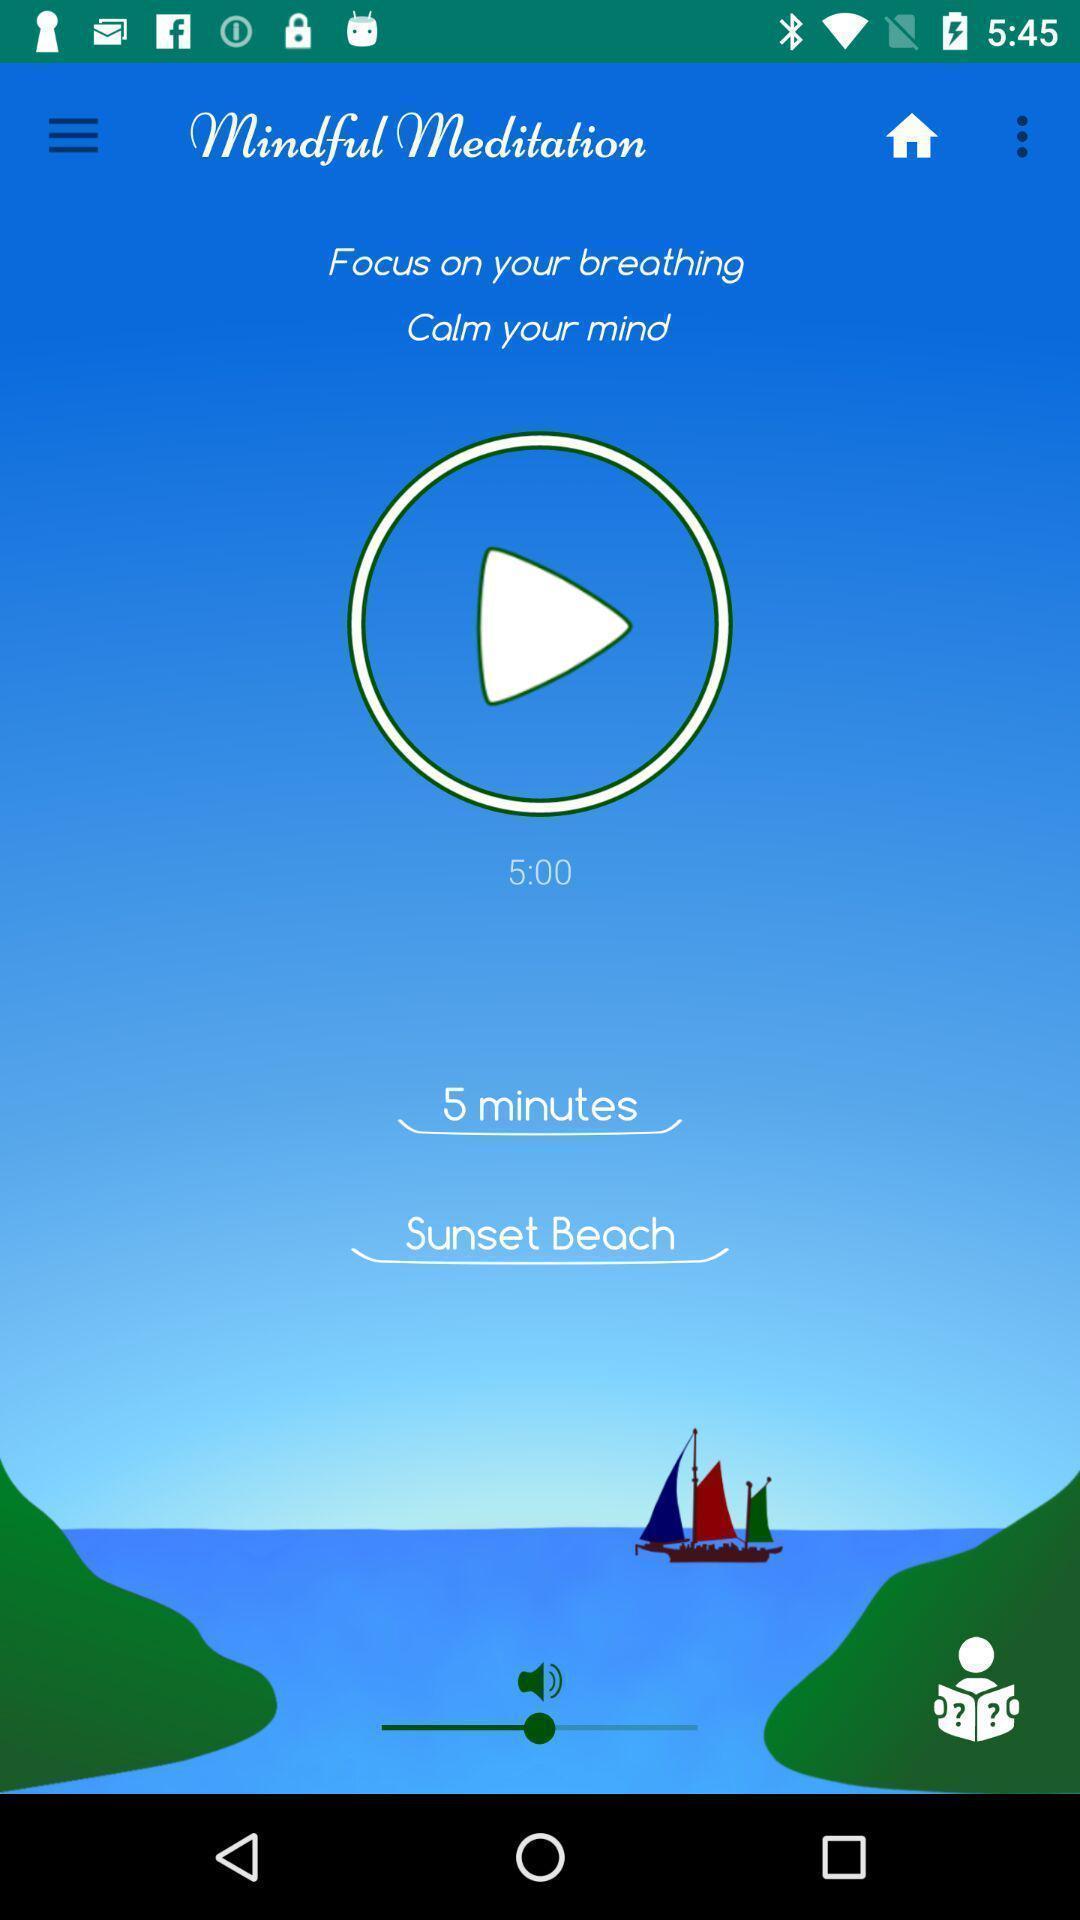Describe the content in this image. Page showing play option. 